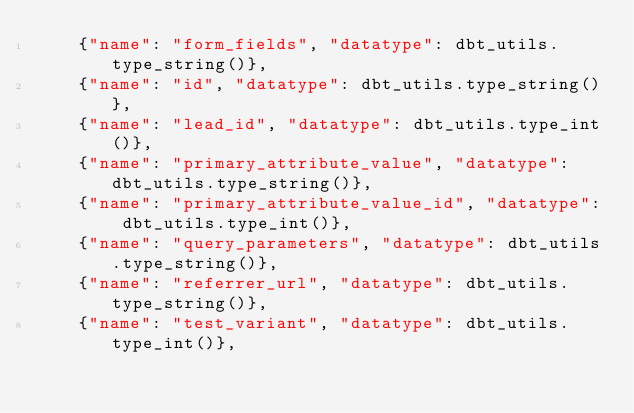Convert code to text. <code><loc_0><loc_0><loc_500><loc_500><_SQL_>    {"name": "form_fields", "datatype": dbt_utils.type_string()},
    {"name": "id", "datatype": dbt_utils.type_string()},
    {"name": "lead_id", "datatype": dbt_utils.type_int()},
    {"name": "primary_attribute_value", "datatype": dbt_utils.type_string()},
    {"name": "primary_attribute_value_id", "datatype": dbt_utils.type_int()},
    {"name": "query_parameters", "datatype": dbt_utils.type_string()},
    {"name": "referrer_url", "datatype": dbt_utils.type_string()},
    {"name": "test_variant", "datatype": dbt_utils.type_int()},</code> 